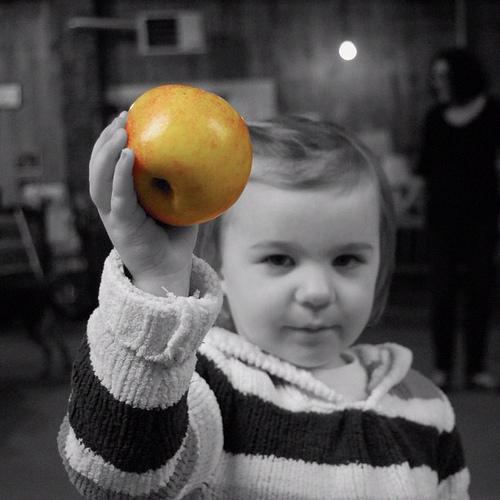How many lights do you see?
Give a very brief answer. 1. How many dark stripes are on the child's sweater?
Give a very brief answer. 2. 